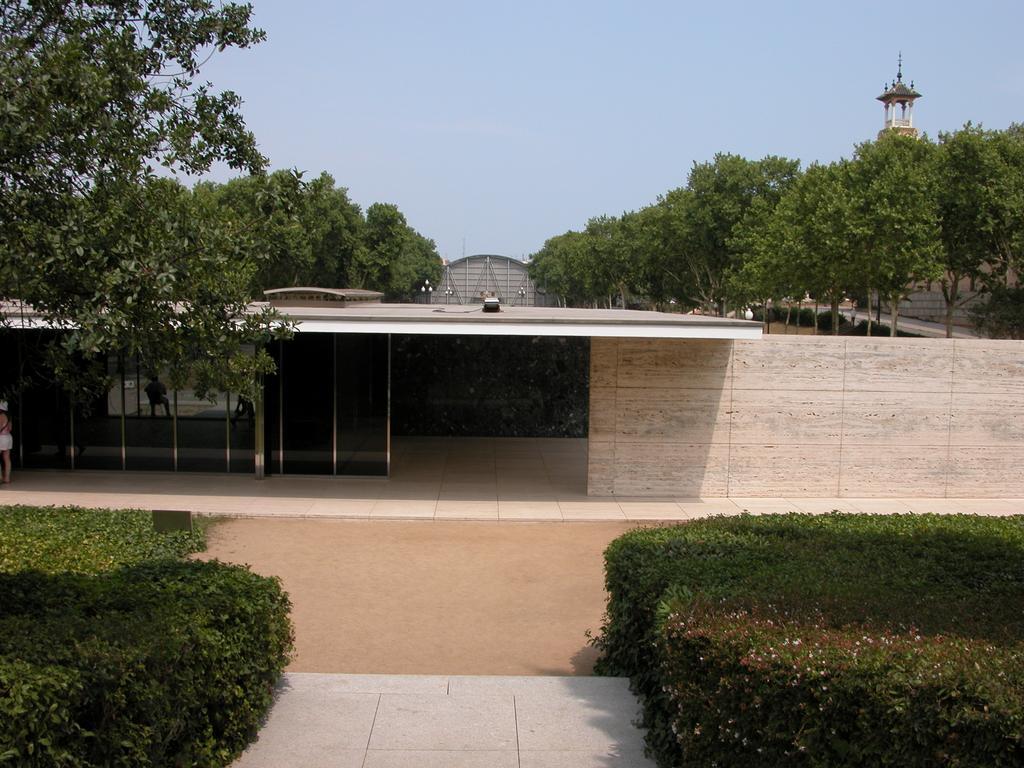Could you give a brief overview of what you see in this image? In this image on the left and right side we can see plants. In the middle we can see path and ground. In the background there are trees, buildings, plants and sky. 